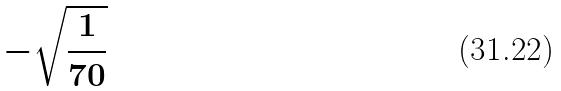Convert formula to latex. <formula><loc_0><loc_0><loc_500><loc_500>- \sqrt { \frac { 1 } { 7 0 } }</formula> 